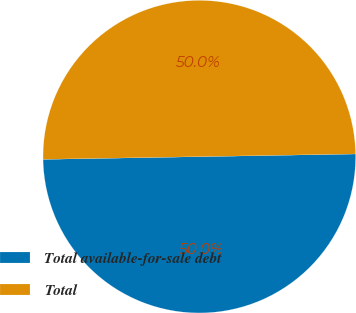<chart> <loc_0><loc_0><loc_500><loc_500><pie_chart><fcel>Total available-for-sale debt<fcel>Total<nl><fcel>50.0%<fcel>50.0%<nl></chart> 